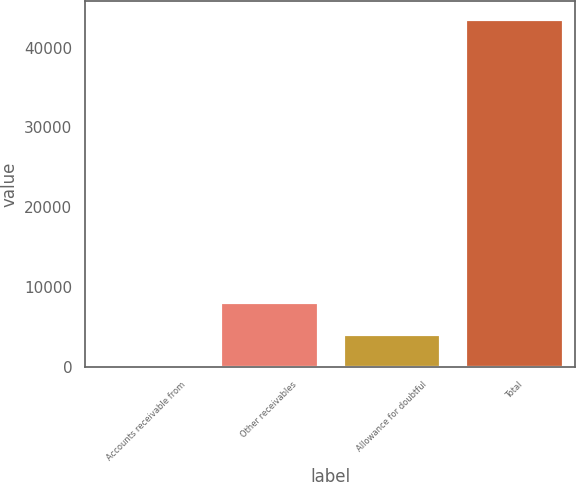Convert chart to OTSL. <chart><loc_0><loc_0><loc_500><loc_500><bar_chart><fcel>Accounts receivable from<fcel>Other receivables<fcel>Allowance for doubtful<fcel>Total<nl><fcel>167<fcel>8130.4<fcel>4148.7<fcel>43608.7<nl></chart> 